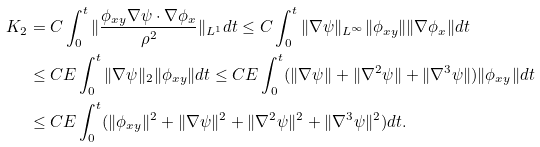Convert formula to latex. <formula><loc_0><loc_0><loc_500><loc_500>K _ { 2 } & = C \int _ { 0 } ^ { t } \| \frac { \phi _ { x y } \nabla \psi \cdot \nabla \phi _ { x } } { \rho ^ { 2 } } \| _ { L ^ { 1 } } d t \leq C \int _ { 0 } ^ { t } \| \nabla \psi \| _ { L ^ { \infty } } \| \phi _ { x y } \| \| \nabla \phi _ { x } \| d t \\ & \leq C E \int _ { 0 } ^ { t } \| \nabla \psi \| _ { 2 } \| \phi _ { x y } \| d t \leq C E \int _ { 0 } ^ { t } ( \| \nabla \psi \| + \| \nabla ^ { 2 } \psi \| + \| \nabla ^ { 3 } \psi \| ) \| \phi _ { x y } \| d t \\ & \leq C E \int _ { 0 } ^ { t } ( \| \phi _ { x y } \| ^ { 2 } + \| \nabla \psi \| ^ { 2 } + \| \nabla ^ { 2 } \psi \| ^ { 2 } + \| \nabla ^ { 3 } \psi \| ^ { 2 } ) d t .</formula> 